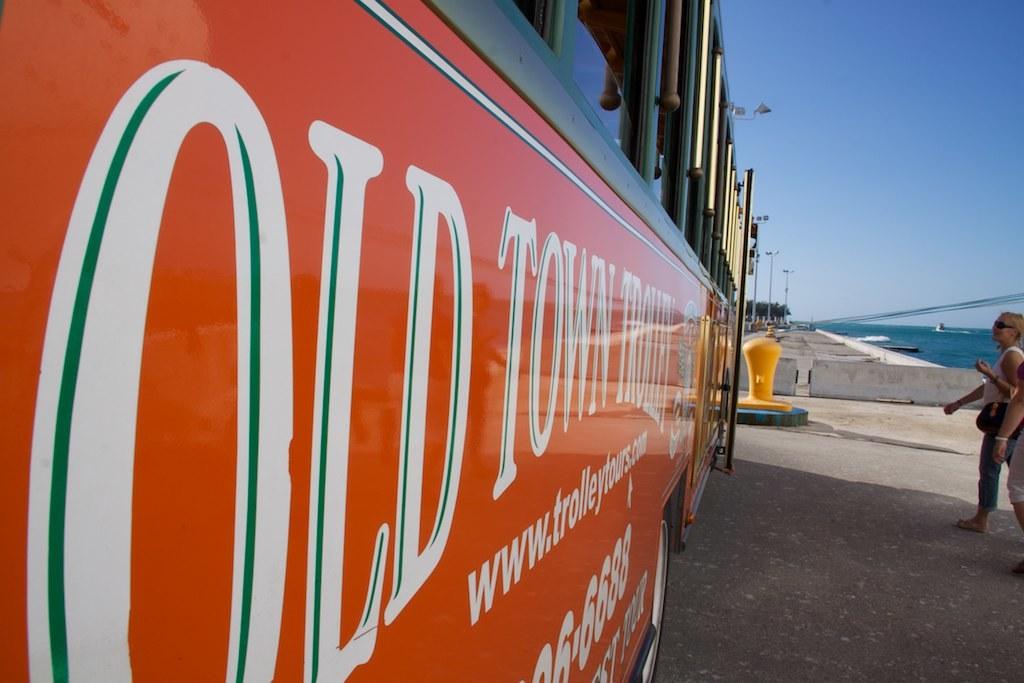What is the name of the trolley?
Give a very brief answer. Old town. What are the last four numbers on the trolley?
Offer a terse response. 6688. 